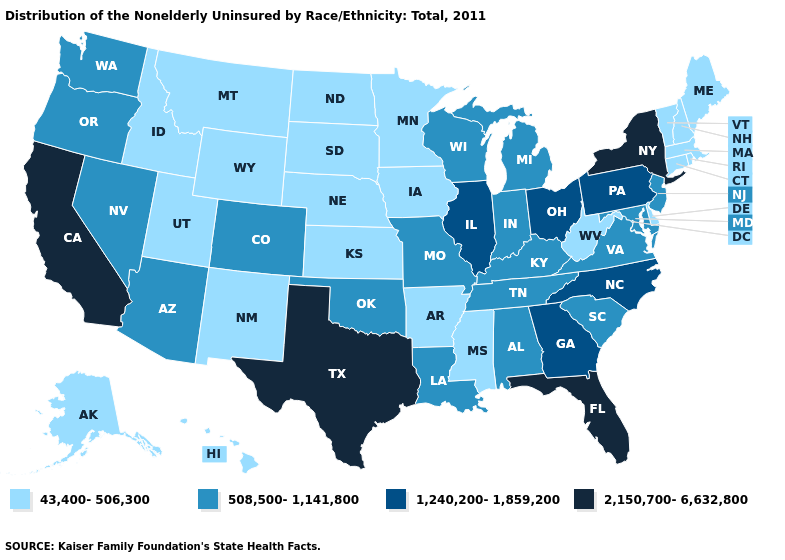Name the states that have a value in the range 508,500-1,141,800?
Keep it brief. Alabama, Arizona, Colorado, Indiana, Kentucky, Louisiana, Maryland, Michigan, Missouri, Nevada, New Jersey, Oklahoma, Oregon, South Carolina, Tennessee, Virginia, Washington, Wisconsin. Name the states that have a value in the range 43,400-506,300?
Be succinct. Alaska, Arkansas, Connecticut, Delaware, Hawaii, Idaho, Iowa, Kansas, Maine, Massachusetts, Minnesota, Mississippi, Montana, Nebraska, New Hampshire, New Mexico, North Dakota, Rhode Island, South Dakota, Utah, Vermont, West Virginia, Wyoming. Name the states that have a value in the range 508,500-1,141,800?
Keep it brief. Alabama, Arizona, Colorado, Indiana, Kentucky, Louisiana, Maryland, Michigan, Missouri, Nevada, New Jersey, Oklahoma, Oregon, South Carolina, Tennessee, Virginia, Washington, Wisconsin. Does Missouri have the same value as New Jersey?
Answer briefly. Yes. Name the states that have a value in the range 1,240,200-1,859,200?
Write a very short answer. Georgia, Illinois, North Carolina, Ohio, Pennsylvania. What is the highest value in the West ?
Short answer required. 2,150,700-6,632,800. What is the value of Nevada?
Write a very short answer. 508,500-1,141,800. Which states have the lowest value in the USA?
Give a very brief answer. Alaska, Arkansas, Connecticut, Delaware, Hawaii, Idaho, Iowa, Kansas, Maine, Massachusetts, Minnesota, Mississippi, Montana, Nebraska, New Hampshire, New Mexico, North Dakota, Rhode Island, South Dakota, Utah, Vermont, West Virginia, Wyoming. Among the states that border West Virginia , does Ohio have the lowest value?
Give a very brief answer. No. Name the states that have a value in the range 43,400-506,300?
Write a very short answer. Alaska, Arkansas, Connecticut, Delaware, Hawaii, Idaho, Iowa, Kansas, Maine, Massachusetts, Minnesota, Mississippi, Montana, Nebraska, New Hampshire, New Mexico, North Dakota, Rhode Island, South Dakota, Utah, Vermont, West Virginia, Wyoming. Does Michigan have a higher value than Iowa?
Give a very brief answer. Yes. Does the map have missing data?
Write a very short answer. No. Does West Virginia have a lower value than Missouri?
Short answer required. Yes. Name the states that have a value in the range 43,400-506,300?
Give a very brief answer. Alaska, Arkansas, Connecticut, Delaware, Hawaii, Idaho, Iowa, Kansas, Maine, Massachusetts, Minnesota, Mississippi, Montana, Nebraska, New Hampshire, New Mexico, North Dakota, Rhode Island, South Dakota, Utah, Vermont, West Virginia, Wyoming. What is the lowest value in the USA?
Short answer required. 43,400-506,300. 